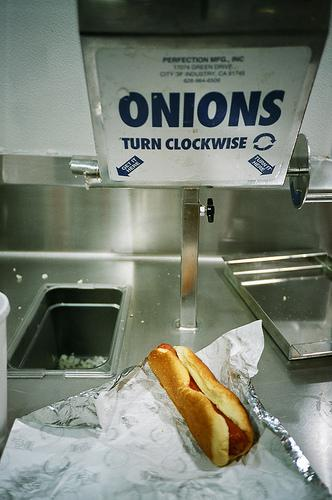Question: what is in the dispenser?
Choices:
A. Onions.
B. Potatoes.
C. Greens.
D. Peas.
Answer with the letter. Answer: A Question: how should the handle be turned to get onions out?
Choices:
A. Right.
B. Back.
C. Clockwise.
D. Towards you.
Answer with the letter. Answer: C Question: what is under the hotdog roll?
Choices:
A. Silver foil.
B. Paper.
C. Napkin.
D. Plate.
Answer with the letter. Answer: A Question: what is in the stainless steel container?
Choices:
A. Veggies.
B. Onions.
C. Food.
D. Garnish.
Answer with the letter. Answer: B 